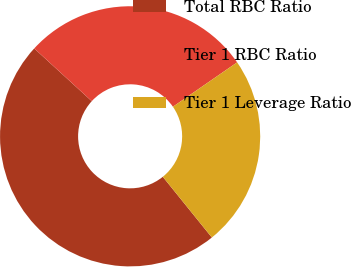Convert chart. <chart><loc_0><loc_0><loc_500><loc_500><pie_chart><fcel>Total RBC Ratio<fcel>Tier 1 RBC Ratio<fcel>Tier 1 Leverage Ratio<nl><fcel>47.62%<fcel>28.57%<fcel>23.81%<nl></chart> 